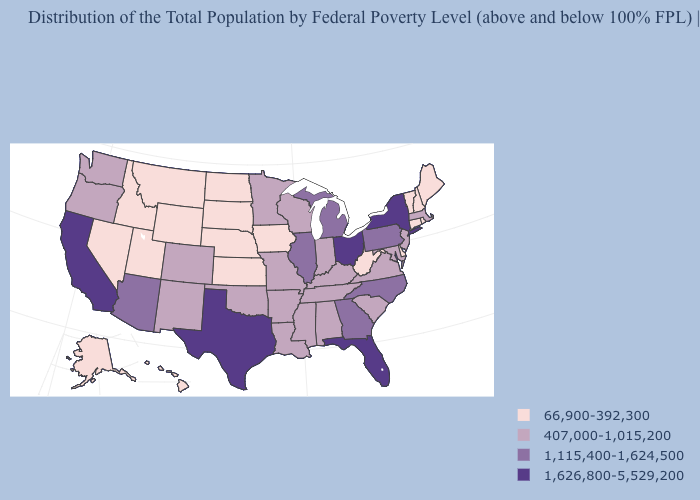Does Texas have the highest value in the USA?
Keep it brief. Yes. What is the value of Maryland?
Be succinct. 407,000-1,015,200. Name the states that have a value in the range 1,115,400-1,624,500?
Concise answer only. Arizona, Georgia, Illinois, Michigan, North Carolina, Pennsylvania. What is the highest value in the West ?
Give a very brief answer. 1,626,800-5,529,200. What is the highest value in the West ?
Keep it brief. 1,626,800-5,529,200. Name the states that have a value in the range 1,115,400-1,624,500?
Answer briefly. Arizona, Georgia, Illinois, Michigan, North Carolina, Pennsylvania. Name the states that have a value in the range 1,115,400-1,624,500?
Concise answer only. Arizona, Georgia, Illinois, Michigan, North Carolina, Pennsylvania. Name the states that have a value in the range 407,000-1,015,200?
Give a very brief answer. Alabama, Arkansas, Colorado, Indiana, Kentucky, Louisiana, Maryland, Massachusetts, Minnesota, Mississippi, Missouri, New Jersey, New Mexico, Oklahoma, Oregon, South Carolina, Tennessee, Virginia, Washington, Wisconsin. What is the value of Hawaii?
Answer briefly. 66,900-392,300. Does the first symbol in the legend represent the smallest category?
Be succinct. Yes. Does the map have missing data?
Quick response, please. No. Among the states that border Tennessee , does Missouri have the highest value?
Keep it brief. No. Does Indiana have a lower value than Hawaii?
Keep it brief. No. Does New York have the highest value in the Northeast?
Write a very short answer. Yes. What is the lowest value in the USA?
Short answer required. 66,900-392,300. 